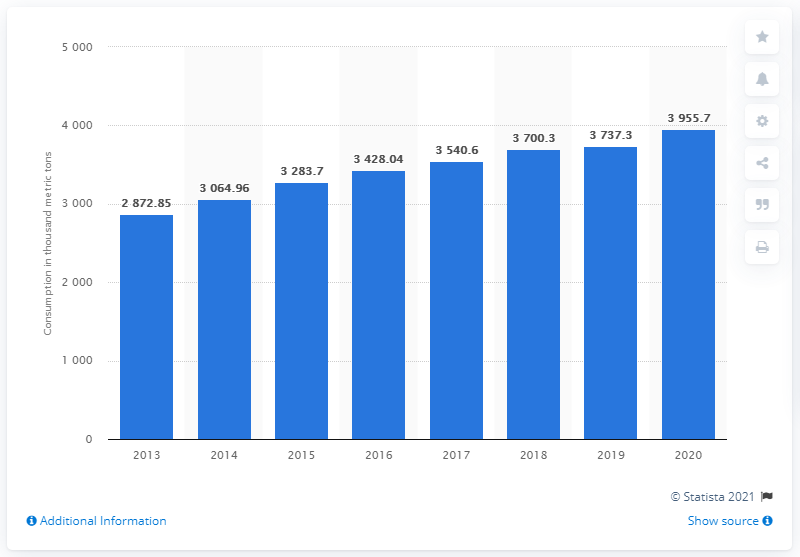Identify some key points in this picture. In 2020, poultry meat consumption in India was found to be over 3.9 million metric tons. 